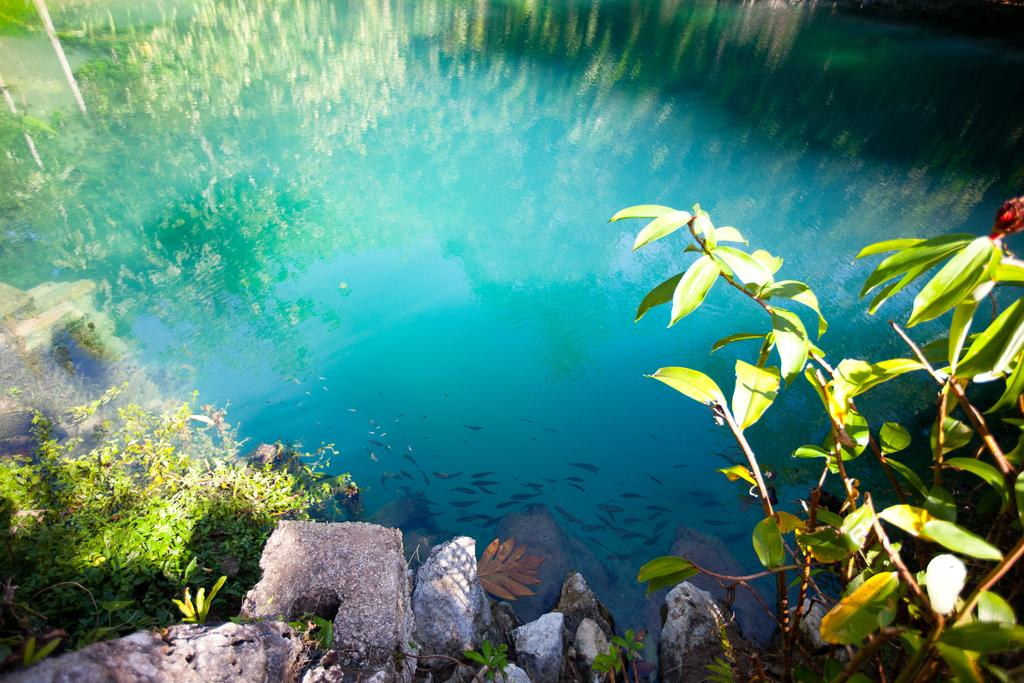What type of natural elements can be seen in the image? There are rocks, plants, and grass visible in the image. Is there any water present in the image? Yes, there are small fish in the water in the image. What type of stomach pain is the person experiencing in the image? There is no person present in the image, and therefore no stomach pain can be observed. 